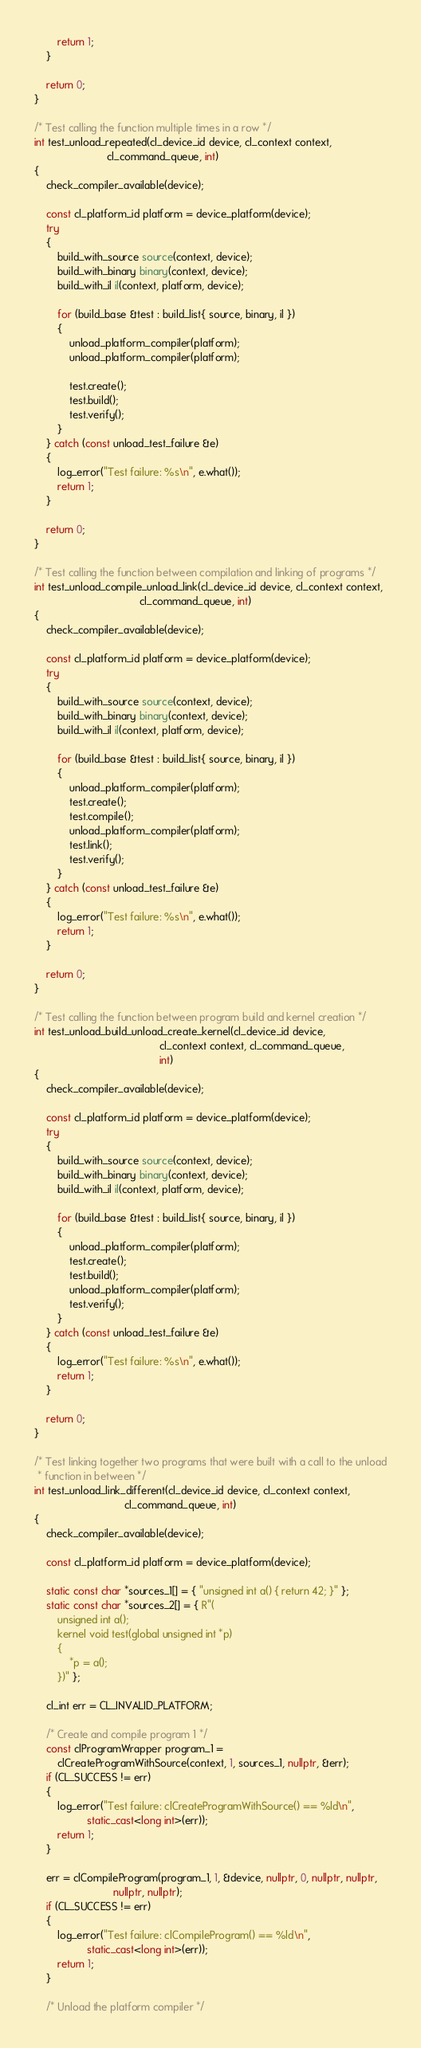<code> <loc_0><loc_0><loc_500><loc_500><_C++_>        return 1;
    }

    return 0;
}

/* Test calling the function multiple times in a row */
int test_unload_repeated(cl_device_id device, cl_context context,
                         cl_command_queue, int)
{
    check_compiler_available(device);

    const cl_platform_id platform = device_platform(device);
    try
    {
        build_with_source source(context, device);
        build_with_binary binary(context, device);
        build_with_il il(context, platform, device);

        for (build_base &test : build_list{ source, binary, il })
        {
            unload_platform_compiler(platform);
            unload_platform_compiler(platform);

            test.create();
            test.build();
            test.verify();
        }
    } catch (const unload_test_failure &e)
    {
        log_error("Test failure: %s\n", e.what());
        return 1;
    }

    return 0;
}

/* Test calling the function between compilation and linking of programs */
int test_unload_compile_unload_link(cl_device_id device, cl_context context,
                                    cl_command_queue, int)
{
    check_compiler_available(device);

    const cl_platform_id platform = device_platform(device);
    try
    {
        build_with_source source(context, device);
        build_with_binary binary(context, device);
        build_with_il il(context, platform, device);

        for (build_base &test : build_list{ source, binary, il })
        {
            unload_platform_compiler(platform);
            test.create();
            test.compile();
            unload_platform_compiler(platform);
            test.link();
            test.verify();
        }
    } catch (const unload_test_failure &e)
    {
        log_error("Test failure: %s\n", e.what());
        return 1;
    }

    return 0;
}

/* Test calling the function between program build and kernel creation */
int test_unload_build_unload_create_kernel(cl_device_id device,
                                           cl_context context, cl_command_queue,
                                           int)
{
    check_compiler_available(device);

    const cl_platform_id platform = device_platform(device);
    try
    {
        build_with_source source(context, device);
        build_with_binary binary(context, device);
        build_with_il il(context, platform, device);

        for (build_base &test : build_list{ source, binary, il })
        {
            unload_platform_compiler(platform);
            test.create();
            test.build();
            unload_platform_compiler(platform);
            test.verify();
        }
    } catch (const unload_test_failure &e)
    {
        log_error("Test failure: %s\n", e.what());
        return 1;
    }

    return 0;
}

/* Test linking together two programs that were built with a call to the unload
 * function in between */
int test_unload_link_different(cl_device_id device, cl_context context,
                               cl_command_queue, int)
{
    check_compiler_available(device);

    const cl_platform_id platform = device_platform(device);

    static const char *sources_1[] = { "unsigned int a() { return 42; }" };
    static const char *sources_2[] = { R"(
		unsigned int a();
		kernel void test(global unsigned int *p)
		{
			*p = a();
		})" };

    cl_int err = CL_INVALID_PLATFORM;

    /* Create and compile program 1 */
    const clProgramWrapper program_1 =
        clCreateProgramWithSource(context, 1, sources_1, nullptr, &err);
    if (CL_SUCCESS != err)
    {
        log_error("Test failure: clCreateProgramWithSource() == %ld\n",
                  static_cast<long int>(err));
        return 1;
    }

    err = clCompileProgram(program_1, 1, &device, nullptr, 0, nullptr, nullptr,
                           nullptr, nullptr);
    if (CL_SUCCESS != err)
    {
        log_error("Test failure: clCompileProgram() == %ld\n",
                  static_cast<long int>(err));
        return 1;
    }

    /* Unload the platform compiler */</code> 